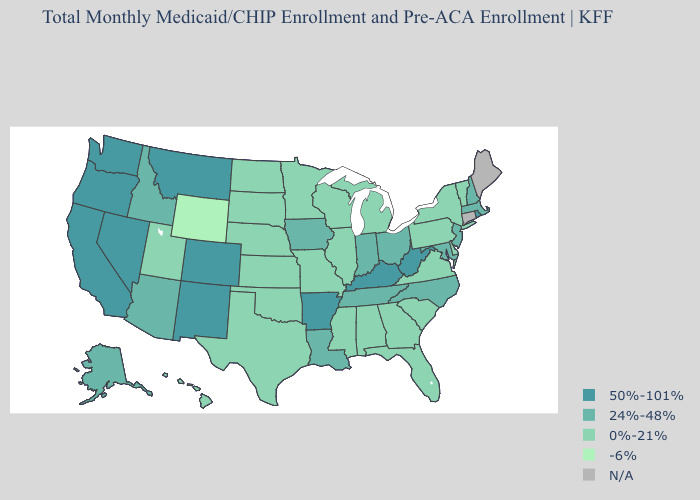Does the map have missing data?
Short answer required. Yes. Does West Virginia have the highest value in the South?
Write a very short answer. Yes. Name the states that have a value in the range -6%?
Concise answer only. Wyoming. Name the states that have a value in the range -6%?
Keep it brief. Wyoming. Name the states that have a value in the range N/A?
Concise answer only. Connecticut, Maine. Among the states that border South Carolina , which have the highest value?
Keep it brief. North Carolina. How many symbols are there in the legend?
Write a very short answer. 5. Name the states that have a value in the range 0%-21%?
Write a very short answer. Alabama, Delaware, Florida, Georgia, Hawaii, Illinois, Kansas, Michigan, Minnesota, Mississippi, Missouri, Nebraska, New York, North Dakota, Oklahoma, Pennsylvania, South Carolina, South Dakota, Texas, Utah, Vermont, Virginia, Wisconsin. What is the lowest value in states that border Vermont?
Be succinct. 0%-21%. Name the states that have a value in the range 0%-21%?
Be succinct. Alabama, Delaware, Florida, Georgia, Hawaii, Illinois, Kansas, Michigan, Minnesota, Mississippi, Missouri, Nebraska, New York, North Dakota, Oklahoma, Pennsylvania, South Carolina, South Dakota, Texas, Utah, Vermont, Virginia, Wisconsin. Among the states that border Georgia , which have the highest value?
Give a very brief answer. North Carolina, Tennessee. What is the value of Kentucky?
Write a very short answer. 50%-101%. What is the value of Missouri?
Concise answer only. 0%-21%. Among the states that border Iowa , which have the highest value?
Answer briefly. Illinois, Minnesota, Missouri, Nebraska, South Dakota, Wisconsin. 